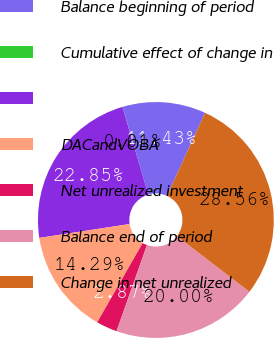<chart> <loc_0><loc_0><loc_500><loc_500><pie_chart><fcel>Balance beginning of period<fcel>Cumulative effect of change in<fcel>Unnamed: 2<fcel>DACandVOBA<fcel>Net unrealized investment<fcel>Balance end of period<fcel>Change in net unrealized<nl><fcel>11.43%<fcel>0.01%<fcel>22.85%<fcel>14.29%<fcel>2.87%<fcel>20.0%<fcel>28.56%<nl></chart> 